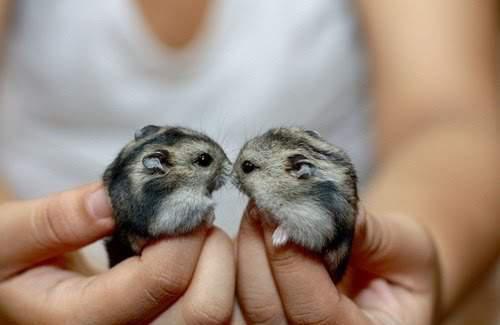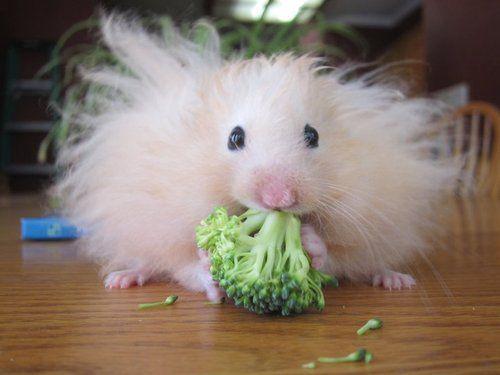The first image is the image on the left, the second image is the image on the right. Examine the images to the left and right. Is the description "An image shows exactly one pet rodent nibbling on a greenish tinged produce item." accurate? Answer yes or no. Yes. The first image is the image on the left, the second image is the image on the right. Evaluate the accuracy of this statement regarding the images: "Two rodents in one of the images are face to face.". Is it true? Answer yes or no. Yes. 